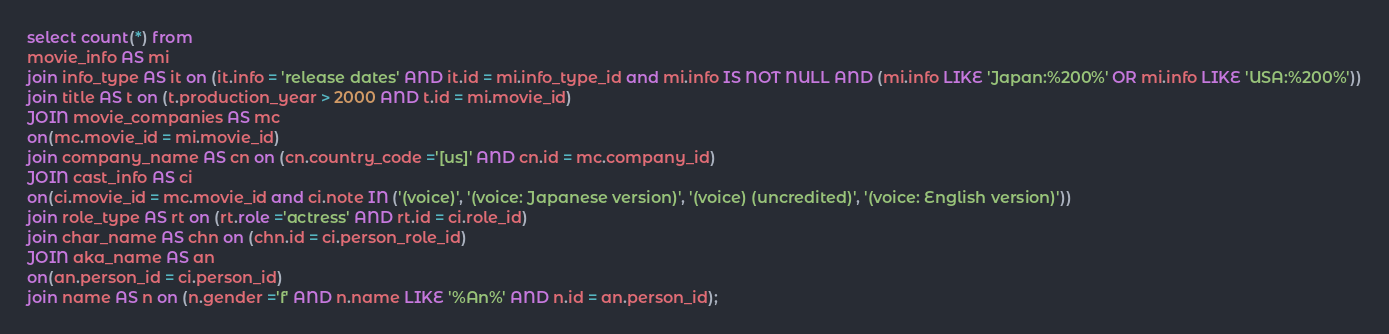Convert code to text. <code><loc_0><loc_0><loc_500><loc_500><_SQL_>select count(*) from 
movie_info AS mi 
join info_type AS it on (it.info = 'release dates' AND it.id = mi.info_type_id and mi.info IS NOT NULL AND (mi.info LIKE 'Japan:%200%' OR mi.info LIKE 'USA:%200%'))
join title AS t on (t.production_year > 2000 AND t.id = mi.movie_id)
JOIN movie_companies AS mc  
on(mc.movie_id = mi.movie_id)
join company_name AS cn on (cn.country_code ='[us]' AND cn.id = mc.company_id)
JOIN cast_info AS ci  
on(ci.movie_id = mc.movie_id and ci.note IN ('(voice)', '(voice: Japanese version)', '(voice) (uncredited)', '(voice: English version)'))
join role_type AS rt on (rt.role ='actress' AND rt.id = ci.role_id)
join char_name AS chn on (chn.id = ci.person_role_id)
JOIN aka_name AS an  
on(an.person_id = ci.person_id)
join name AS n on (n.gender ='f' AND n.name LIKE '%An%' AND n.id = an.person_id);</code> 